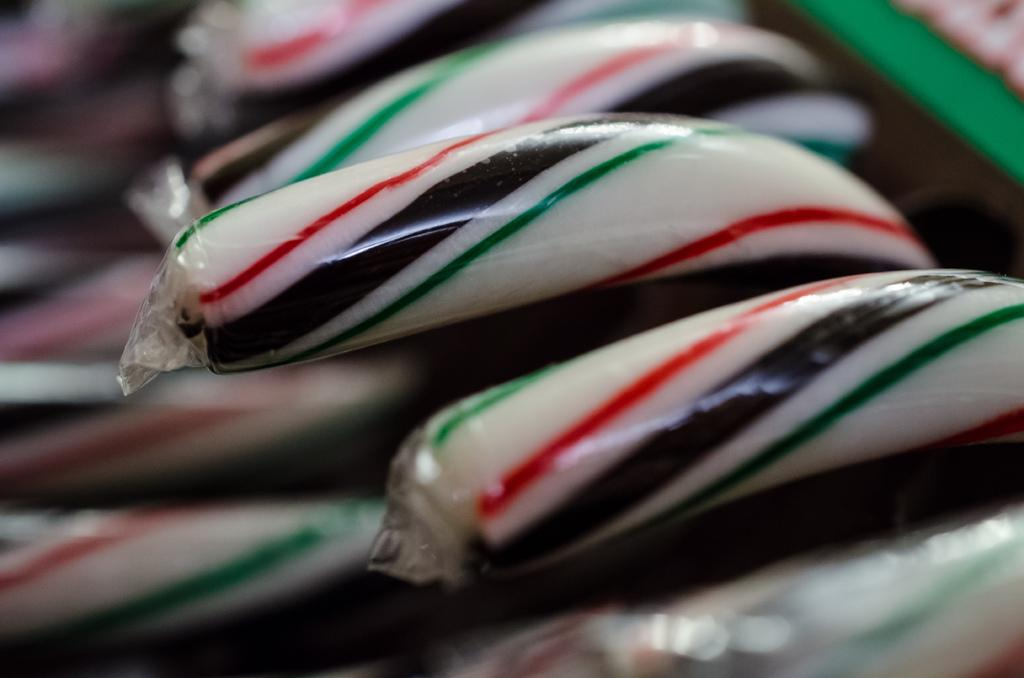What type of food can be seen in the image? There are chocolates in the image. How are the chocolates presented in the image? The chocolates are packed. What letter is written on the patch of the visitor in the image? There is no visitor or patch present in the image; it only features chocolates that are packed. 